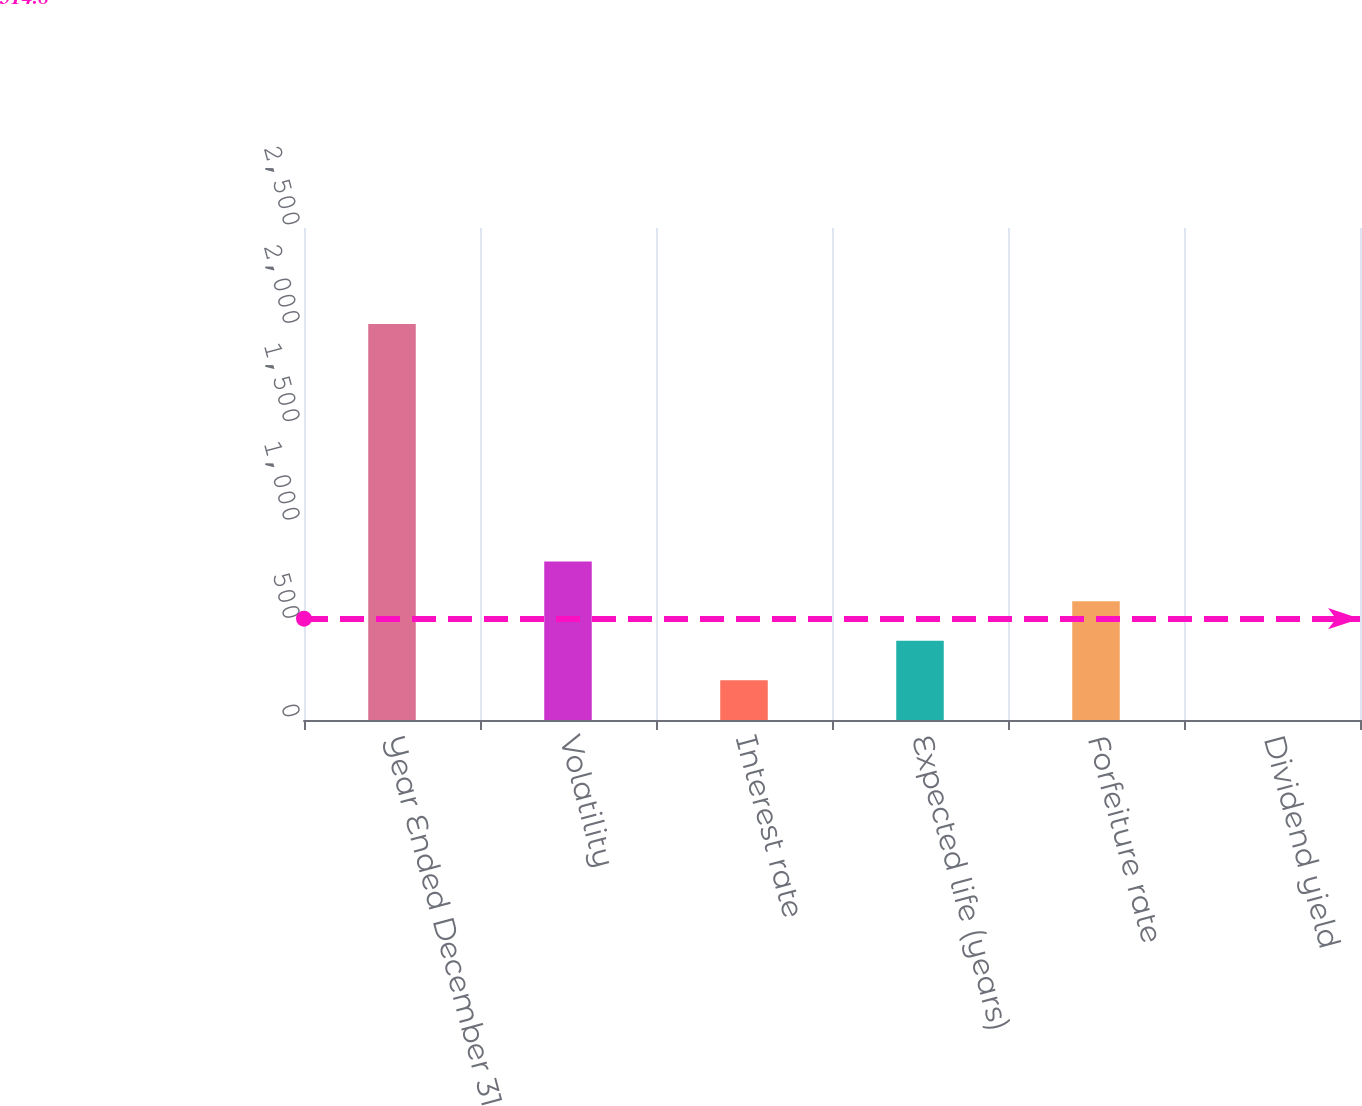Convert chart to OTSL. <chart><loc_0><loc_0><loc_500><loc_500><bar_chart><fcel>Year Ended December 31<fcel>Volatility<fcel>Interest rate<fcel>Expected life (years)<fcel>Forfeiture rate<fcel>Dividend yield<nl><fcel>2012<fcel>805.16<fcel>201.74<fcel>402.88<fcel>604.02<fcel>0.6<nl></chart> 